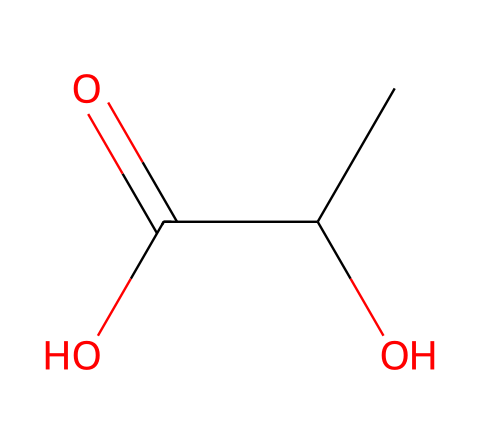How many carbon atoms are in lactic acid? By examining the SMILES, we see "CC" indicates 2 carbon atoms and there are no other carbon fragments present, confirming the total.
Answer: 3 What functional groups are present in lactic acid? The structure shows a hydroxyl group (–OH) and a carboxylic acid group (–COOH), which are indicative of alcoholic and acidic functionalities.
Answer: hydroxyl, carboxylic acid What is the molecular formula of lactic acid? By counting the number of each atom from the structure: 3 carbon (C), 6 hydrogen (H), and 2 oxygen (O), the molecular formula is determined as C3H6O3.
Answer: C3H6O3 What type of bond connects the carbon atoms in lactic acid? The carbon atoms are single-bonded to each other in the structure, as indicated by the absence of double or triple bonds in the carbon-carbon connections.
Answer: single bonds What property of lactic acid allows it to form in muscles during exercise? The formation of lactic acid is due to anaerobic metabolism in muscles when oxygen is scarce, which is typical during intense exercise leading to energy deficit.
Answer: anaerobic metabolism How many oxygen atoms are present in lactic acid? The SMILES notation shows two oxygen atoms denoted by the "O" characters, allowing us to confirm the count directly from the structure.
Answer: 3 